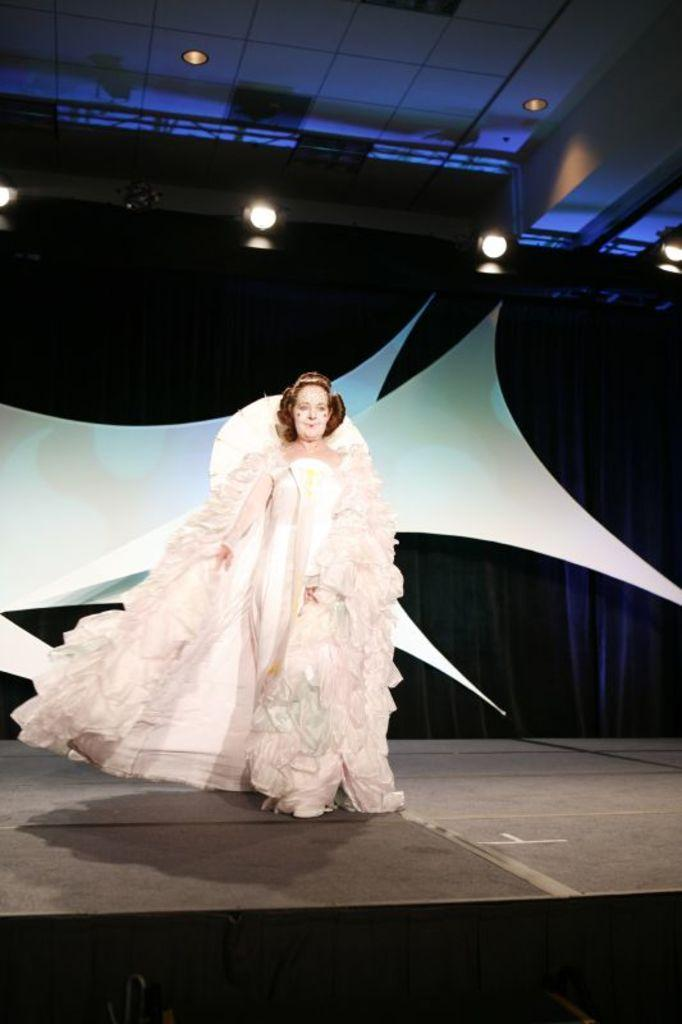What is happening on the stage in the image? There is a person standing on the stage in the image. What is located behind the person on the stage? There is a curtain at the back of the stage. What can be seen above the stage in the image? There is a ceiling with lights visible at the top of the image. How many feet are visible on the bridge in the image? There is no bridge present in the image; it features a person standing on a stage with a curtain and a ceiling with lights. 